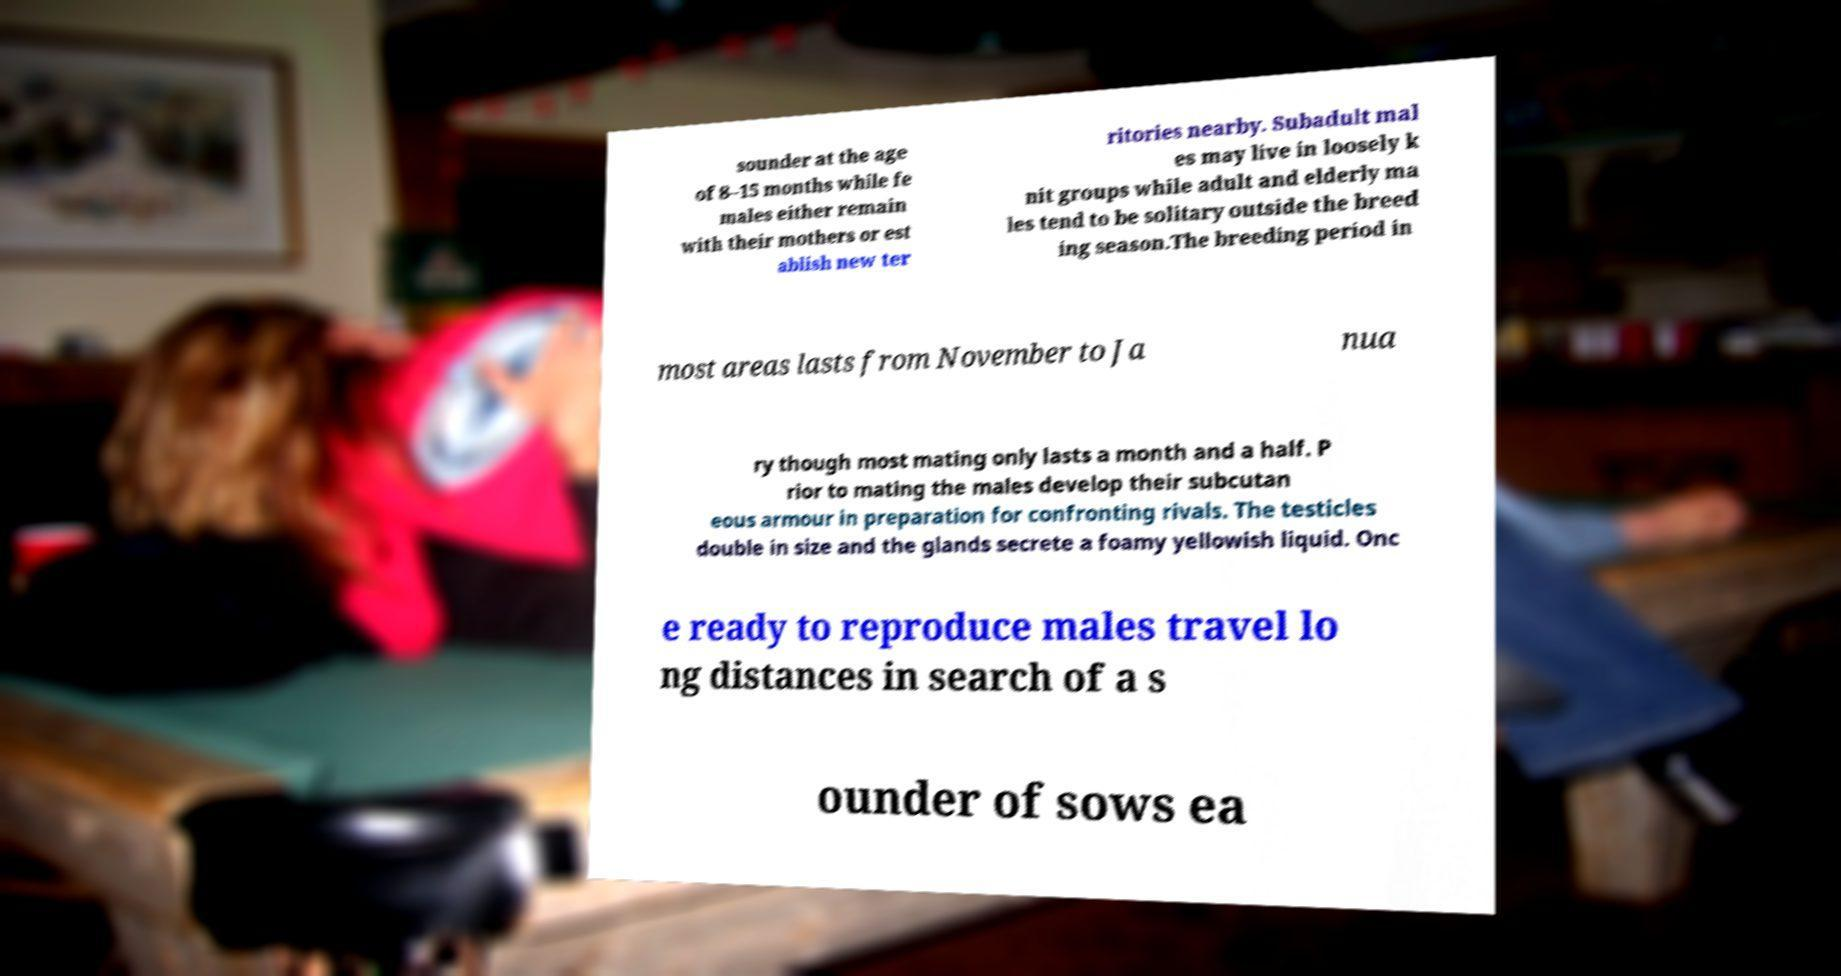I need the written content from this picture converted into text. Can you do that? sounder at the age of 8–15 months while fe males either remain with their mothers or est ablish new ter ritories nearby. Subadult mal es may live in loosely k nit groups while adult and elderly ma les tend to be solitary outside the breed ing season.The breeding period in most areas lasts from November to Ja nua ry though most mating only lasts a month and a half. P rior to mating the males develop their subcutan eous armour in preparation for confronting rivals. The testicles double in size and the glands secrete a foamy yellowish liquid. Onc e ready to reproduce males travel lo ng distances in search of a s ounder of sows ea 